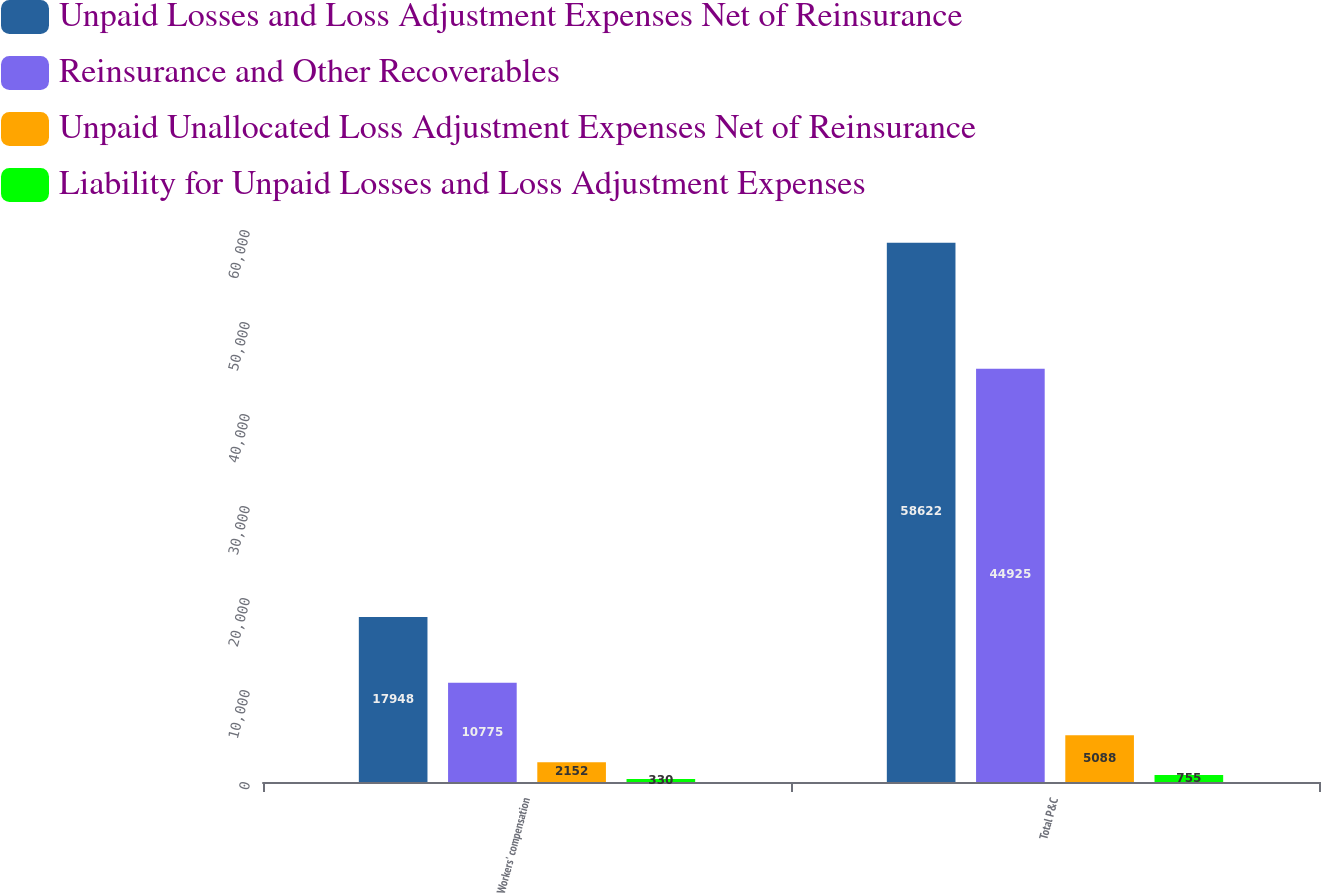Convert chart. <chart><loc_0><loc_0><loc_500><loc_500><stacked_bar_chart><ecel><fcel>Workers' compensation<fcel>Total P&C<nl><fcel>Unpaid Losses and Loss Adjustment Expenses Net of Reinsurance<fcel>17948<fcel>58622<nl><fcel>Reinsurance and Other Recoverables<fcel>10775<fcel>44925<nl><fcel>Unpaid Unallocated Loss Adjustment Expenses Net of Reinsurance<fcel>2152<fcel>5088<nl><fcel>Liability for Unpaid Losses and Loss Adjustment Expenses<fcel>330<fcel>755<nl></chart> 